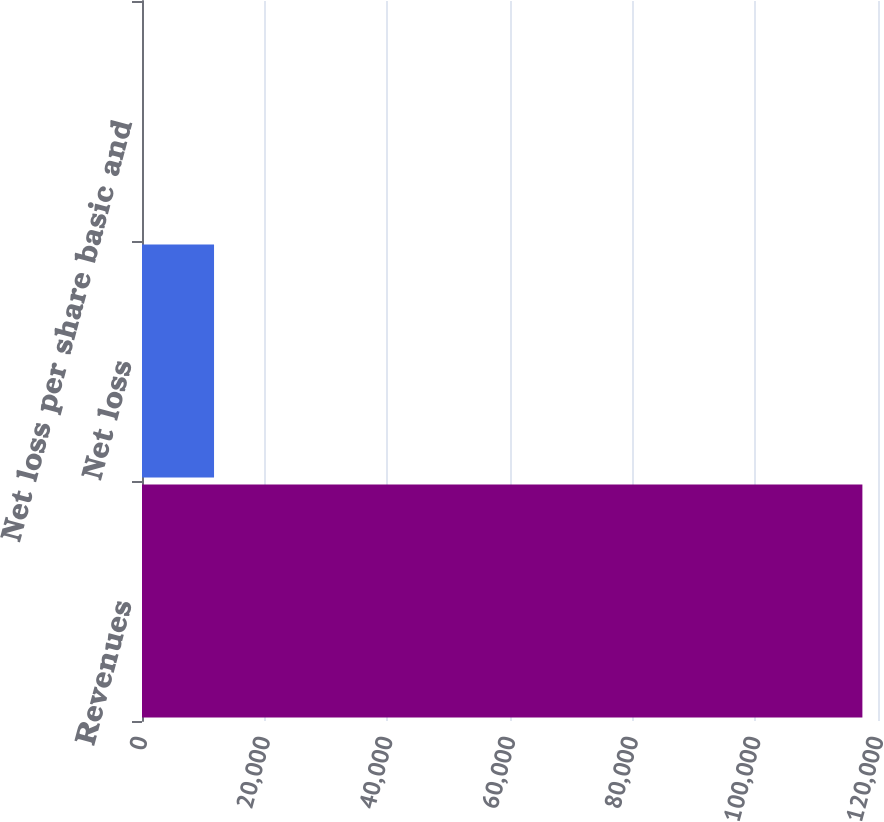Convert chart to OTSL. <chart><loc_0><loc_0><loc_500><loc_500><bar_chart><fcel>Revenues<fcel>Net loss<fcel>Net loss per share basic and<nl><fcel>117455<fcel>11745.5<fcel>0.01<nl></chart> 